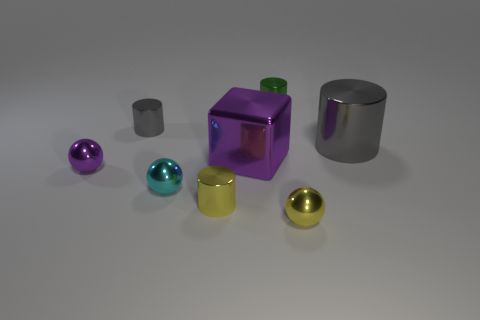Add 1 large gray metallic cylinders. How many objects exist? 9 Subtract all big cylinders. How many cylinders are left? 3 Subtract all yellow cylinders. How many cylinders are left? 3 Subtract all blocks. How many objects are left? 7 Subtract all tiny cyan things. Subtract all shiny cylinders. How many objects are left? 3 Add 5 tiny purple balls. How many tiny purple balls are left? 6 Add 7 tiny purple things. How many tiny purple things exist? 8 Subtract 0 cyan cylinders. How many objects are left? 8 Subtract all cyan blocks. Subtract all purple cylinders. How many blocks are left? 1 Subtract all green cubes. How many yellow cylinders are left? 1 